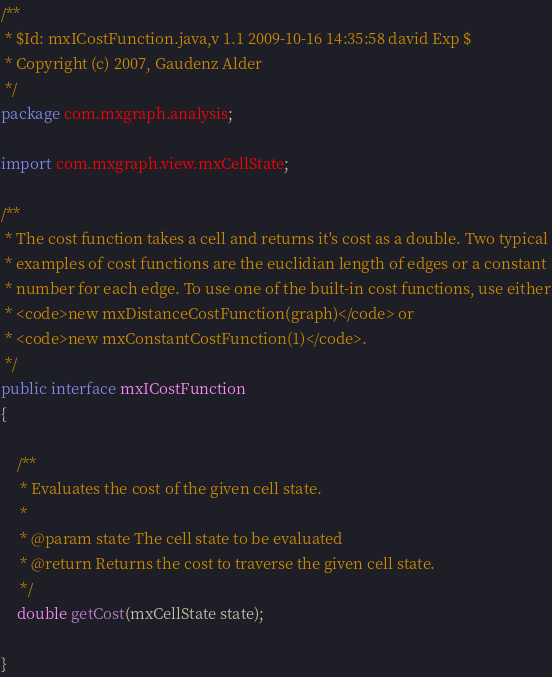<code> <loc_0><loc_0><loc_500><loc_500><_Java_>/**
 * $Id: mxICostFunction.java,v 1.1 2009-10-16 14:35:58 david Exp $
 * Copyright (c) 2007, Gaudenz Alder
 */
package com.mxgraph.analysis;

import com.mxgraph.view.mxCellState;

/**
 * The cost function takes a cell and returns it's cost as a double. Two typical
 * examples of cost functions are the euclidian length of edges or a constant
 * number for each edge. To use one of the built-in cost functions, use either
 * <code>new mxDistanceCostFunction(graph)</code> or
 * <code>new mxConstantCostFunction(1)</code>.
 */
public interface mxICostFunction
{

	/**
	 * Evaluates the cost of the given cell state.
	 * 
	 * @param state The cell state to be evaluated
	 * @return Returns the cost to traverse the given cell state.
	 */
	double getCost(mxCellState state);

}
</code> 